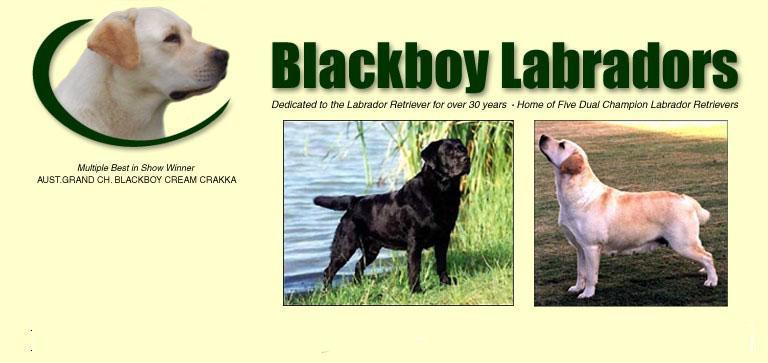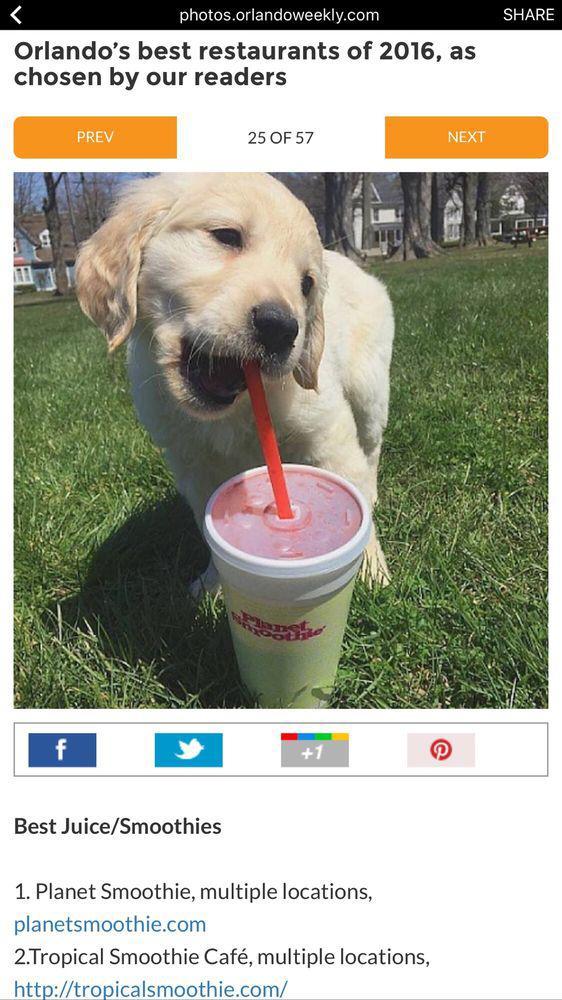The first image is the image on the left, the second image is the image on the right. Assess this claim about the two images: "One dog in the left image has its tongue out.". Correct or not? Answer yes or no. No. 